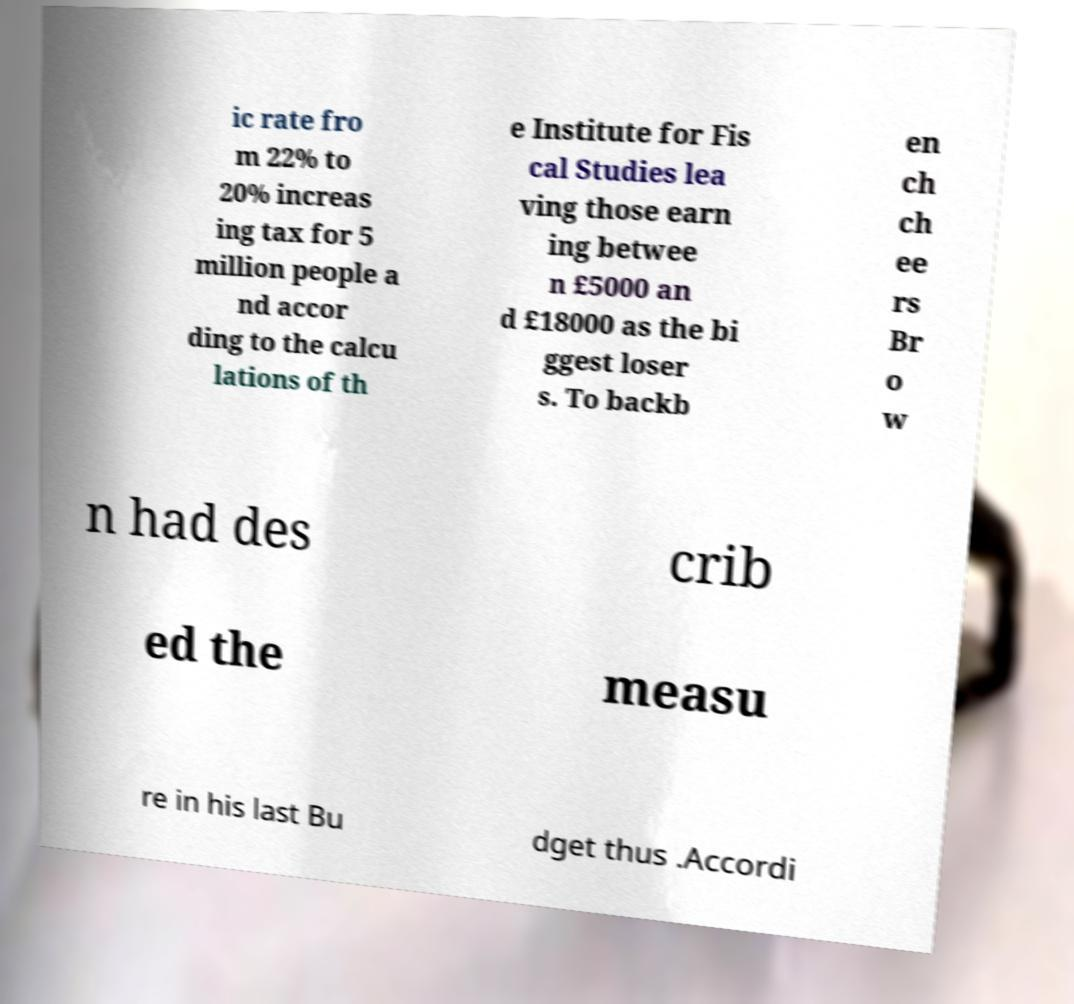Please identify and transcribe the text found in this image. ic rate fro m 22% to 20% increas ing tax for 5 million people a nd accor ding to the calcu lations of th e Institute for Fis cal Studies lea ving those earn ing betwee n £5000 an d £18000 as the bi ggest loser s. To backb en ch ch ee rs Br o w n had des crib ed the measu re in his last Bu dget thus .Accordi 